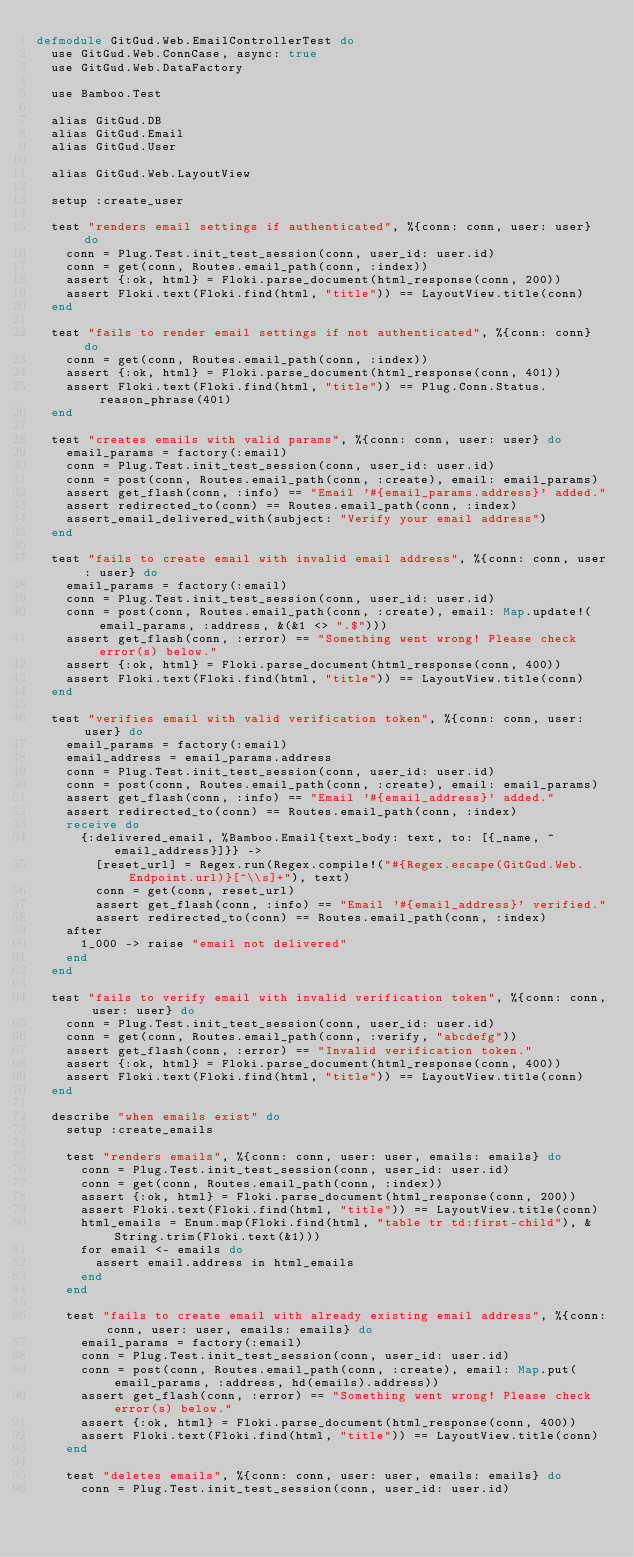Convert code to text. <code><loc_0><loc_0><loc_500><loc_500><_Elixir_>defmodule GitGud.Web.EmailControllerTest do
  use GitGud.Web.ConnCase, async: true
  use GitGud.Web.DataFactory

  use Bamboo.Test

  alias GitGud.DB
  alias GitGud.Email
  alias GitGud.User

  alias GitGud.Web.LayoutView

  setup :create_user

  test "renders email settings if authenticated", %{conn: conn, user: user} do
    conn = Plug.Test.init_test_session(conn, user_id: user.id)
    conn = get(conn, Routes.email_path(conn, :index))
    assert {:ok, html} = Floki.parse_document(html_response(conn, 200))
    assert Floki.text(Floki.find(html, "title")) == LayoutView.title(conn)
  end

  test "fails to render email settings if not authenticated", %{conn: conn} do
    conn = get(conn, Routes.email_path(conn, :index))
    assert {:ok, html} = Floki.parse_document(html_response(conn, 401))
    assert Floki.text(Floki.find(html, "title")) == Plug.Conn.Status.reason_phrase(401)
  end

  test "creates emails with valid params", %{conn: conn, user: user} do
    email_params = factory(:email)
    conn = Plug.Test.init_test_session(conn, user_id: user.id)
    conn = post(conn, Routes.email_path(conn, :create), email: email_params)
    assert get_flash(conn, :info) == "Email '#{email_params.address}' added."
    assert redirected_to(conn) == Routes.email_path(conn, :index)
    assert_email_delivered_with(subject: "Verify your email address")
  end

  test "fails to create email with invalid email address", %{conn: conn, user: user} do
    email_params = factory(:email)
    conn = Plug.Test.init_test_session(conn, user_id: user.id)
    conn = post(conn, Routes.email_path(conn, :create), email: Map.update!(email_params, :address, &(&1 <> ".$")))
    assert get_flash(conn, :error) == "Something went wrong! Please check error(s) below."
    assert {:ok, html} = Floki.parse_document(html_response(conn, 400))
    assert Floki.text(Floki.find(html, "title")) == LayoutView.title(conn)
  end

  test "verifies email with valid verification token", %{conn: conn, user: user} do
    email_params = factory(:email)
    email_address = email_params.address
    conn = Plug.Test.init_test_session(conn, user_id: user.id)
    conn = post(conn, Routes.email_path(conn, :create), email: email_params)
    assert get_flash(conn, :info) == "Email '#{email_address}' added."
    assert redirected_to(conn) == Routes.email_path(conn, :index)
    receive do
      {:delivered_email, %Bamboo.Email{text_body: text, to: [{_name, ^email_address}]}} ->
        [reset_url] = Regex.run(Regex.compile!("#{Regex.escape(GitGud.Web.Endpoint.url)}[^\\s]+"), text)
        conn = get(conn, reset_url)
        assert get_flash(conn, :info) == "Email '#{email_address}' verified."
        assert redirected_to(conn) == Routes.email_path(conn, :index)
    after
      1_000 -> raise "email not delivered"
    end
  end

  test "fails to verify email with invalid verification token", %{conn: conn, user: user} do
    conn = Plug.Test.init_test_session(conn, user_id: user.id)
    conn = get(conn, Routes.email_path(conn, :verify, "abcdefg"))
    assert get_flash(conn, :error) == "Invalid verification token."
    assert {:ok, html} = Floki.parse_document(html_response(conn, 400))
    assert Floki.text(Floki.find(html, "title")) == LayoutView.title(conn)
  end

  describe "when emails exist" do
    setup :create_emails

    test "renders emails", %{conn: conn, user: user, emails: emails} do
      conn = Plug.Test.init_test_session(conn, user_id: user.id)
      conn = get(conn, Routes.email_path(conn, :index))
      assert {:ok, html} = Floki.parse_document(html_response(conn, 200))
      assert Floki.text(Floki.find(html, "title")) == LayoutView.title(conn)
      html_emails = Enum.map(Floki.find(html, "table tr td:first-child"), &String.trim(Floki.text(&1)))
      for email <- emails do
        assert email.address in html_emails
      end
    end

    test "fails to create email with already existing email address", %{conn: conn, user: user, emails: emails} do
      email_params = factory(:email)
      conn = Plug.Test.init_test_session(conn, user_id: user.id)
      conn = post(conn, Routes.email_path(conn, :create), email: Map.put(email_params, :address, hd(emails).address))
      assert get_flash(conn, :error) == "Something went wrong! Please check error(s) below."
      assert {:ok, html} = Floki.parse_document(html_response(conn, 400))
      assert Floki.text(Floki.find(html, "title")) == LayoutView.title(conn)
    end

    test "deletes emails", %{conn: conn, user: user, emails: emails} do
      conn = Plug.Test.init_test_session(conn, user_id: user.id)</code> 